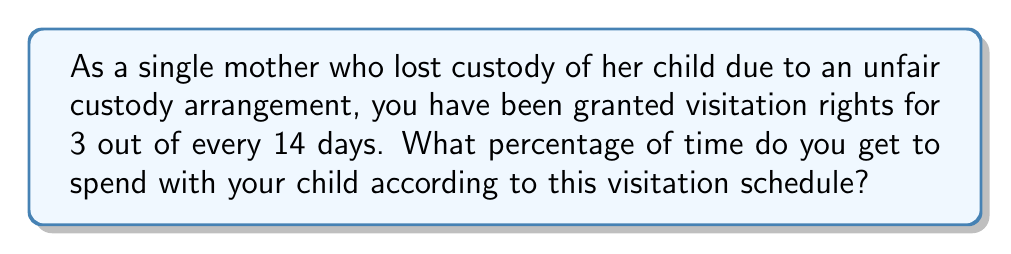Teach me how to tackle this problem. To solve this problem, we need to convert the fraction of days into a percentage. Let's break it down step-by-step:

1. First, we have the fraction of days: 3 out of 14 days.
   This can be written as a fraction: $\frac{3}{14}$

2. To convert a fraction to a percentage, we multiply it by 100:
   $$\frac{3}{14} \times 100 = \frac{300}{14}$$

3. Now, we need to perform the division:
   $$\frac{300}{14} = 21.4285714...$$

4. Rounding to two decimal places, we get 21.43%

Therefore, according to this visitation schedule, you get to spend 21.43% of the time with your child.
Answer: 21.43% 